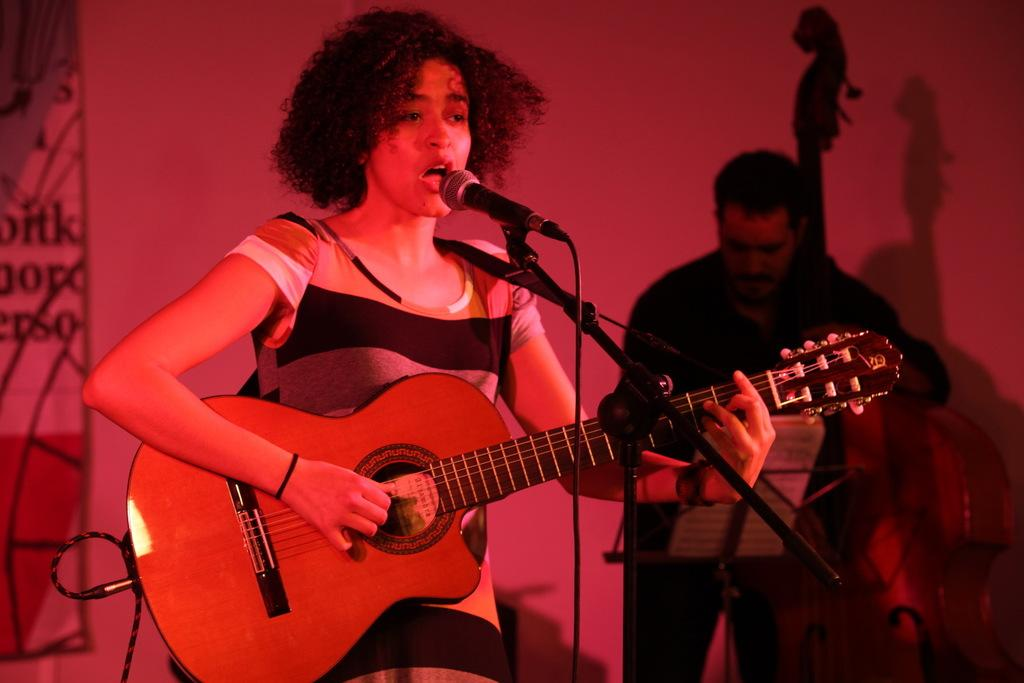What is the lady in the image doing? The lady is playing a guitar in the image. What object is in front of the lady? There is a microphone in front of the lady. What is the man in the background of the image doing? The man is playing a musical instrument in the background of the image. What color is the background of the image? The background of the image is red in color. What decision did the sponge make in the image? There is no sponge present in the image, so it cannot make any decisions. 